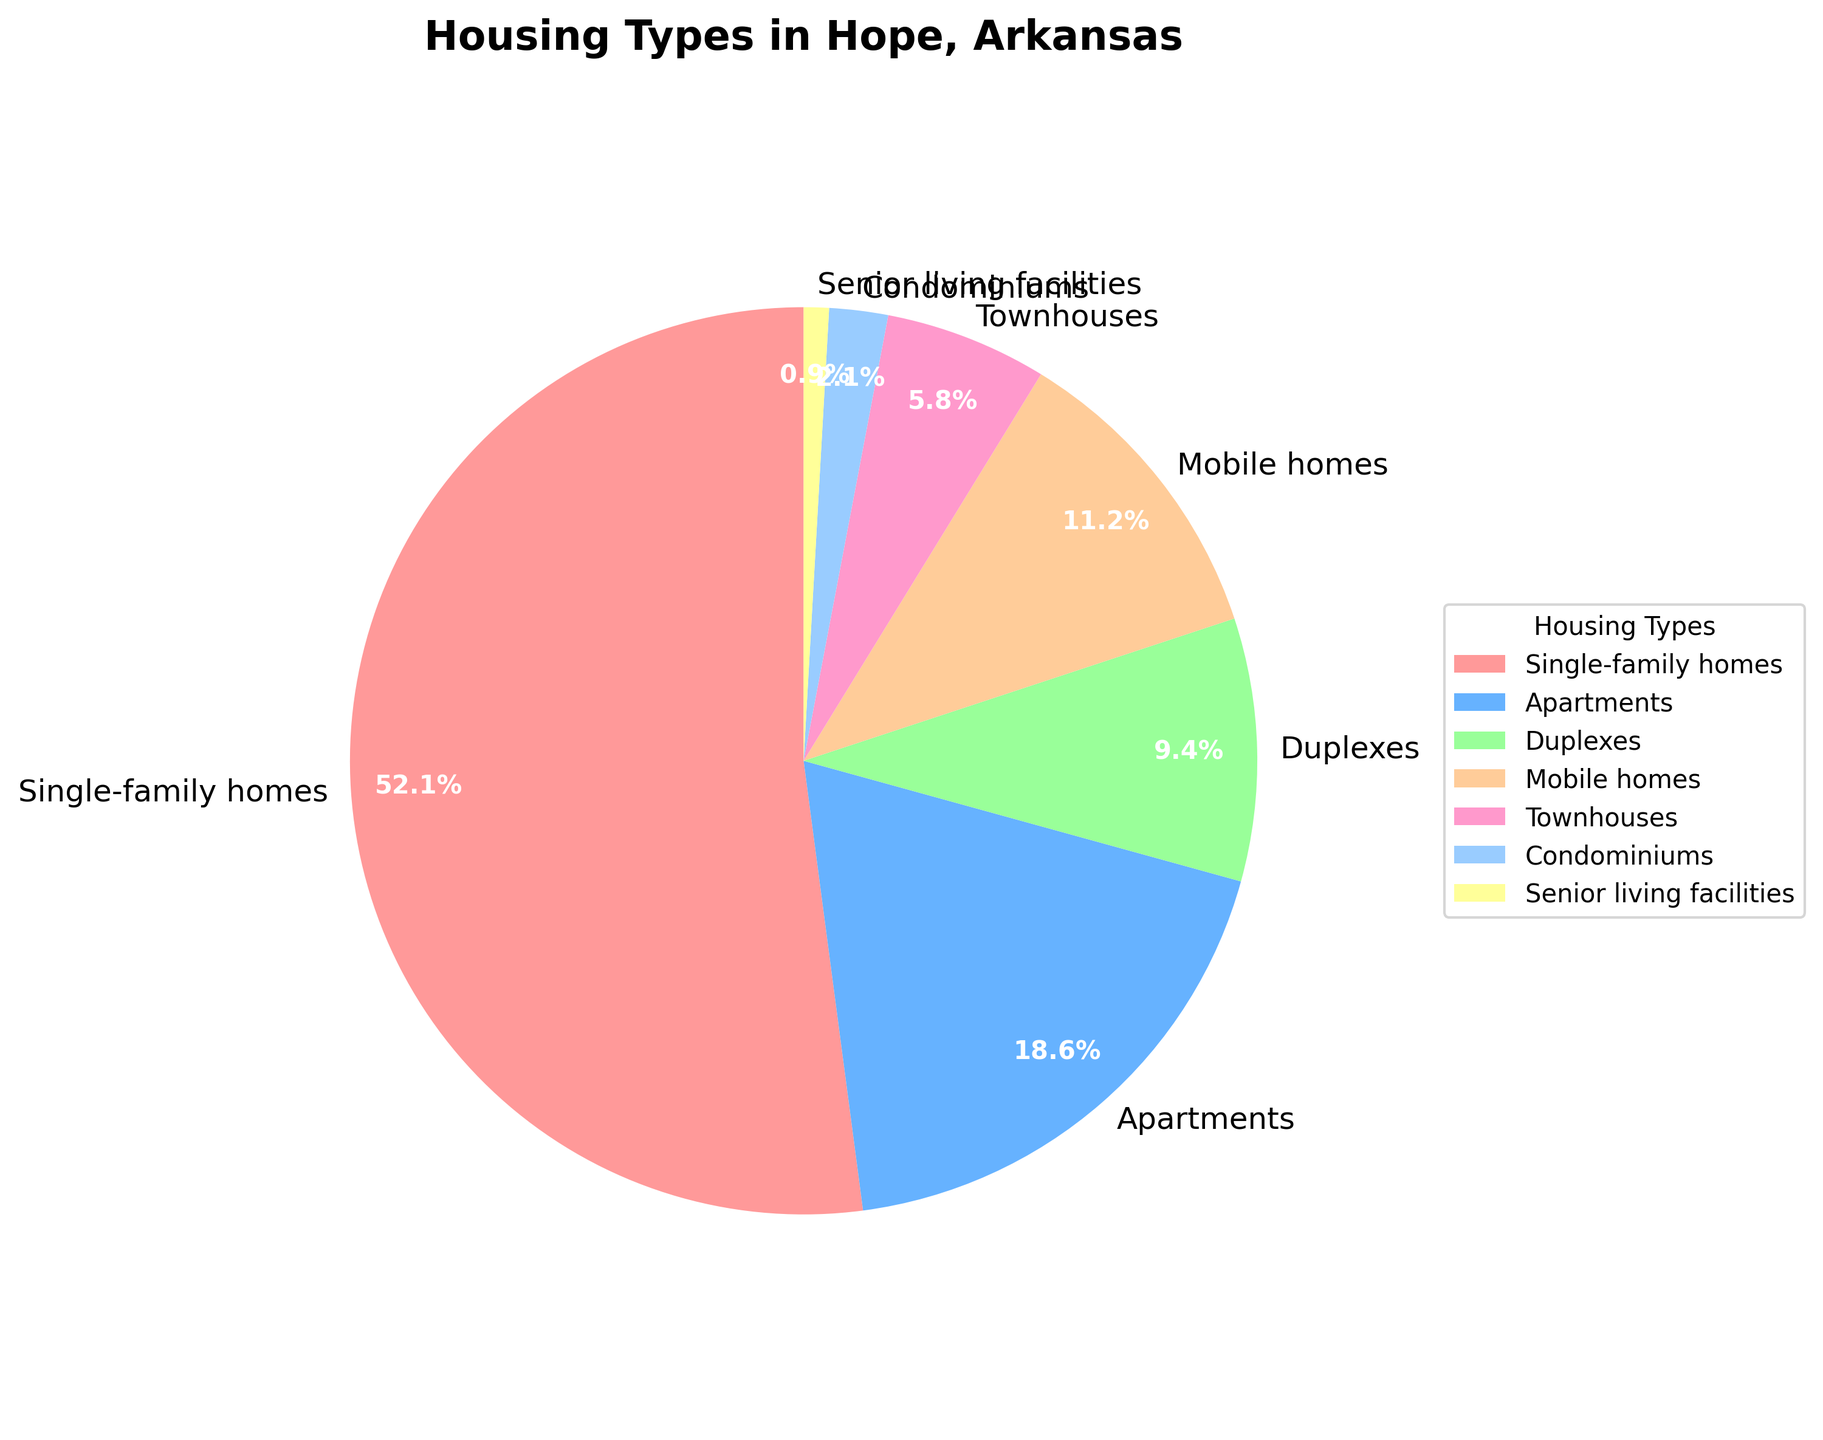What proportion of housing types consists of single-family homes and duplexes combined? To find the combined proportion, add the percentages of single-family homes and duplexes. According to the data, single-family homes are 52.3% and duplexes are 9.4%. The sum is 52.3% + 9.4% = 61.7%.
Answer: 61.7% Which housing type has the smallest proportion in Hope, Arkansas? Among the percentages listed, senior living facilities have the smallest proportion at 0.9%.
Answer: Senior living facilities Are there more single-family homes or apartments? By how much? Single-family homes are 52.3%, while apartments are 18.7%. To find the difference, subtract apartments from single-family homes: 52.3% - 18.7% = 33.6%.
Answer: Single-family homes by 33.6% What is the combined percentage of apartments, mobile homes, and townhouses? Sum the percentages of apartments (18.7%), mobile homes (11.2%), and townhouses (5.8%). The combined percentage is 18.7% + 11.2% + 5.8% = 35.7%.
Answer: 35.7% Compare the proportion of mobile homes to condominiums. Mobile homes constitute 11.2% and condominiums 2.1%. Mobile homes have a larger proportion.
Answer: Mobile homes What is the difference between the proportions of single-family homes and senior living facilities? Subtract the percentage of senior living facilities (0.9%) from single-family homes (52.3%): 52.3% - 0.9% = 51.4%.
Answer: 51.4% Which housing type is represented with the color green in the pie chart? According to the custom colors array and standard pie chart colors, the green segment represents "mobile homes."
Answer: Mobile homes Is the proportion of duplexes closer to the proportion of townhouses or mobile homes? Duplexes are 9.4%; townhouses are 5.8%, a difference of 9.4% - 5.8% = 3.6%. Mobile homes are 11.2%, a difference of 11.2% - 9.4% = 1.8%. The proportion of duplexes is closer to the proportion of mobile homes.
Answer: Mobile homes List the housing types in descending order of their proportion. Based on the data: 1) Single-family homes (52.3%), 2) Apartments (18.7%), 3) Mobile homes (11.2%), 4) Duplexes (9.4%), 5) Townhouses (5.8%), 6) Condominiums (2.1%), 7) Senior living facilities (0.9%).
Answer: Single-family homes, Apartments, Mobile homes, Duplexes, Townhouses, Condominiums, Senior living facilities 